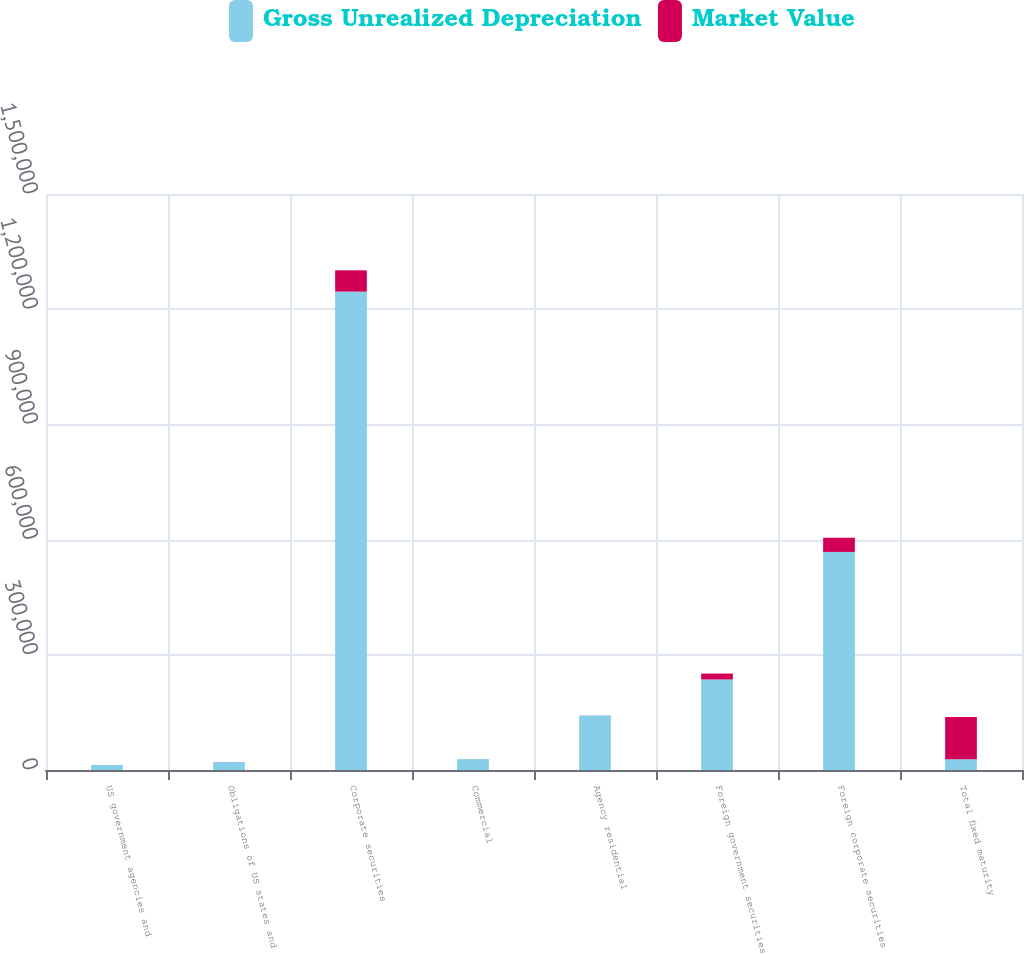Convert chart. <chart><loc_0><loc_0><loc_500><loc_500><stacked_bar_chart><ecel><fcel>US government agencies and<fcel>Obligations of US states and<fcel>Corporate securities<fcel>Commercial<fcel>Agency residential<fcel>Foreign government securities<fcel>Foreign corporate securities<fcel>Total fixed maturity<nl><fcel>Gross Unrealized Depreciation<fcel>13187<fcel>20428<fcel>1.24583e+06<fcel>28191<fcel>141807<fcel>235725<fcel>567905<fcel>28191<nl><fcel>Market Value<fcel>20<fcel>242<fcel>55388<fcel>123<fcel>172<fcel>15415<fcel>36926<fcel>109516<nl></chart> 